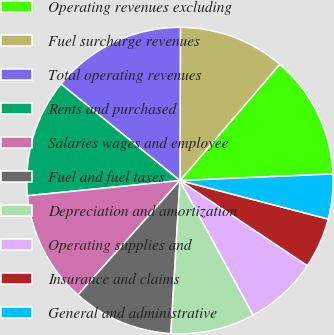<chart> <loc_0><loc_0><loc_500><loc_500><pie_chart><fcel>Operating revenues excluding<fcel>Fuel surcharge revenues<fcel>Total operating revenues<fcel>Rents and purchased<fcel>Salaries wages and employee<fcel>Fuel and fuel taxes<fcel>Depreciation and amortization<fcel>Operating supplies and<fcel>Insurance and claims<fcel>General and administrative<nl><fcel>13.02%<fcel>11.24%<fcel>14.2%<fcel>12.43%<fcel>11.83%<fcel>10.65%<fcel>8.88%<fcel>7.69%<fcel>5.33%<fcel>4.73%<nl></chart> 